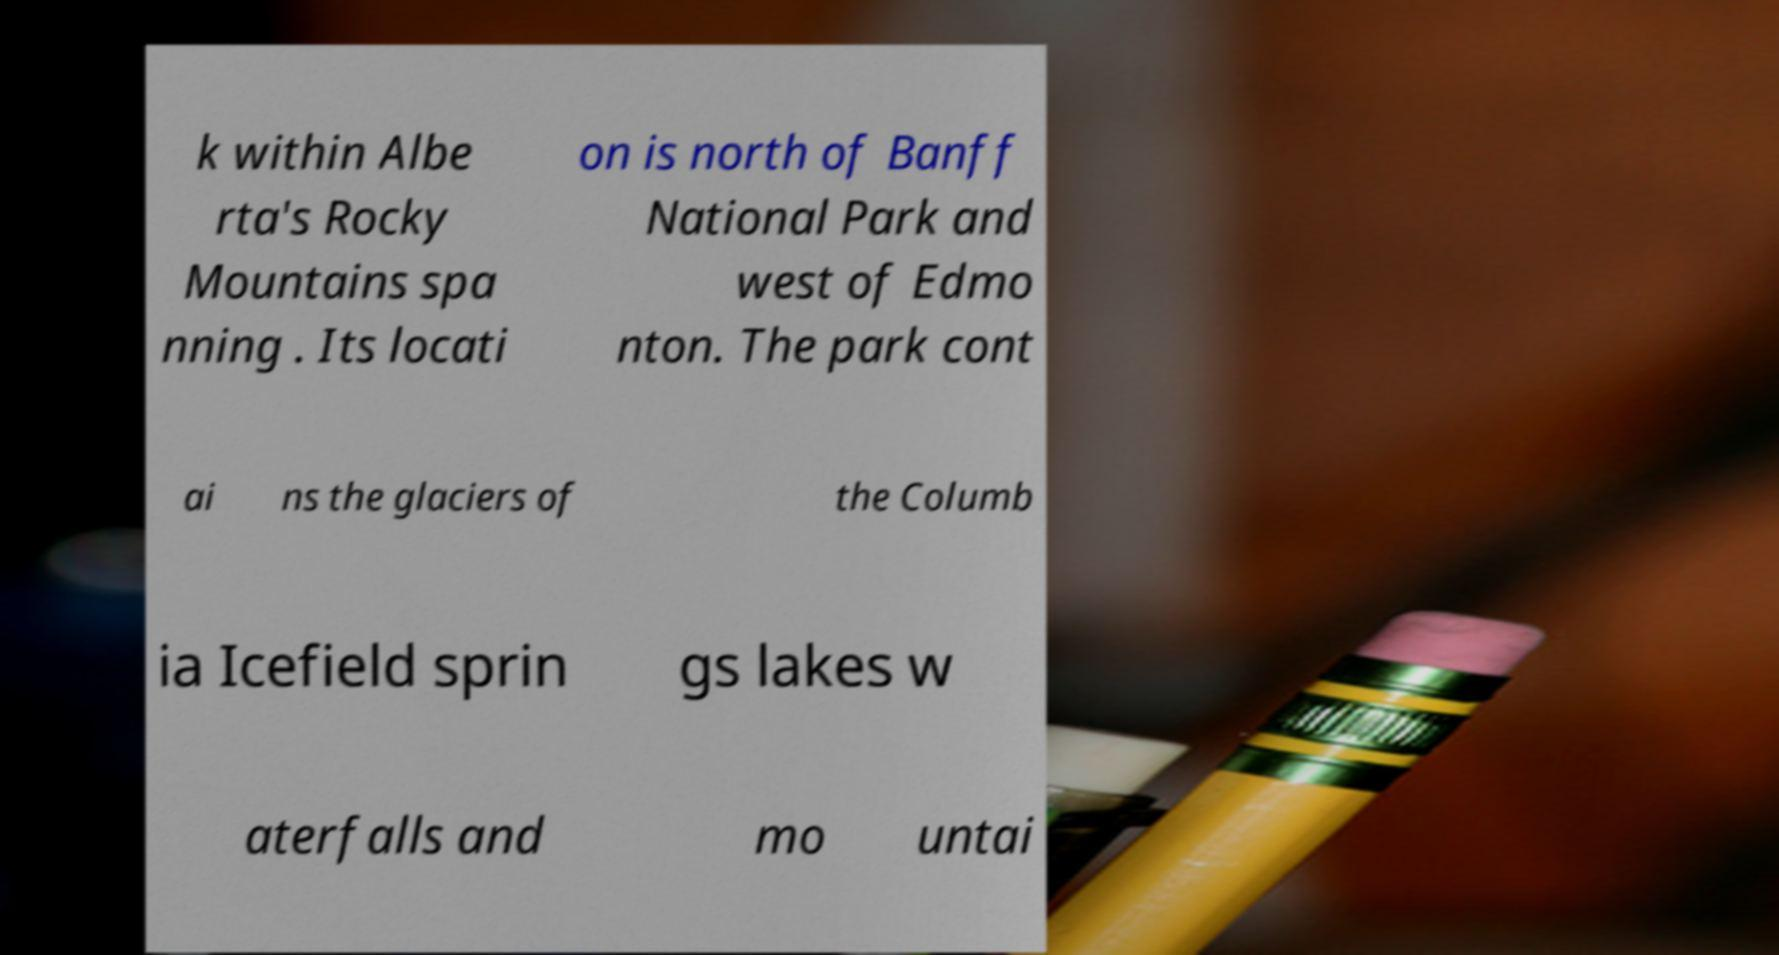Please read and relay the text visible in this image. What does it say? k within Albe rta's Rocky Mountains spa nning . Its locati on is north of Banff National Park and west of Edmo nton. The park cont ai ns the glaciers of the Columb ia Icefield sprin gs lakes w aterfalls and mo untai 